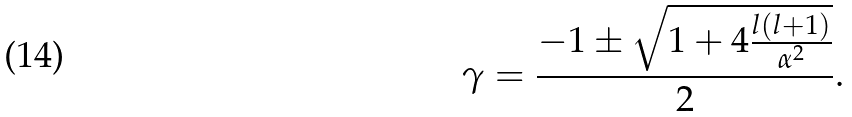<formula> <loc_0><loc_0><loc_500><loc_500>\gamma = \frac { - 1 \pm \sqrt { 1 + 4 \frac { l ( l + 1 ) } { \alpha ^ { 2 } } } } { 2 } .</formula> 